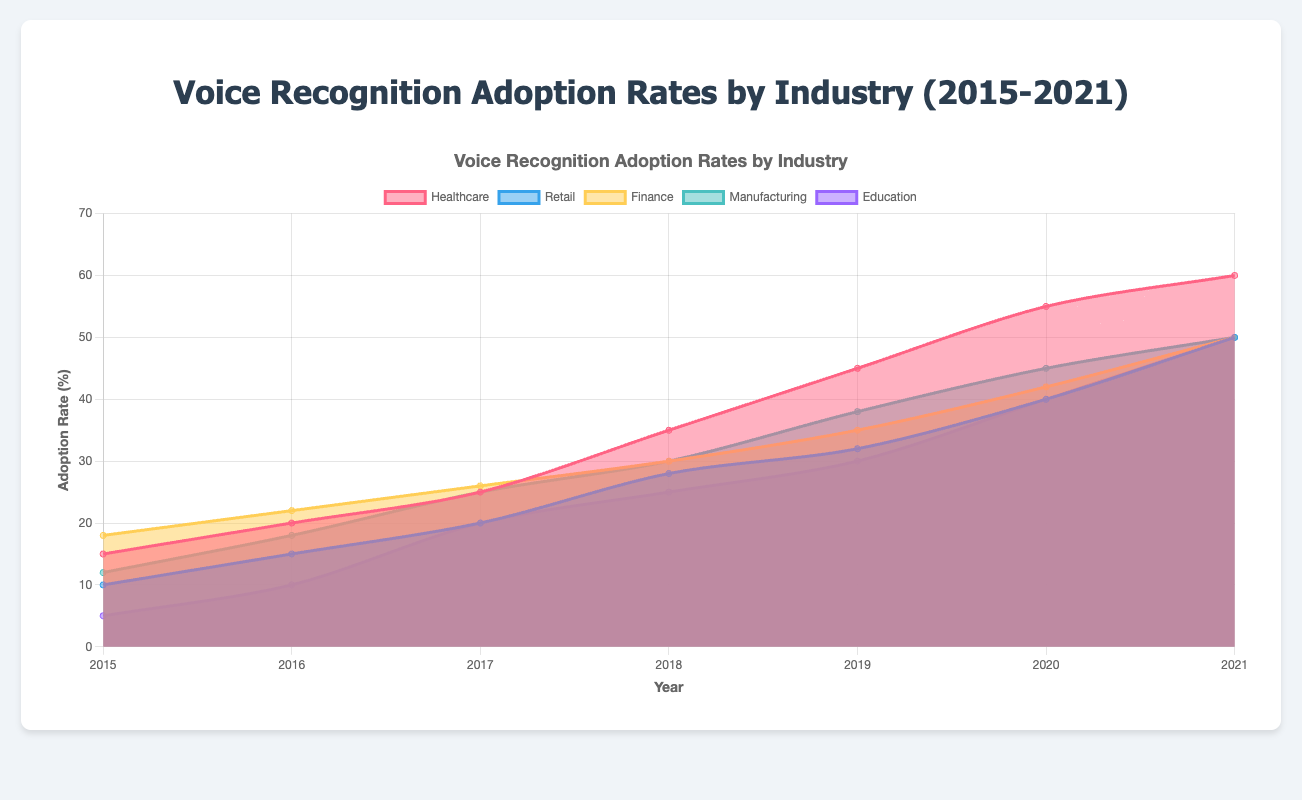What is the title of the chart? The title of the chart is displayed at the top and reads "Voice Recognition Adoption Rates by Industry (2015-2021)."
Answer: Voice Recognition Adoption Rates by Industry (2015-2021) Which industry had the highest adoption rate of voice recognition systems in 2021? The highest adoption rate in 2021 can be identified by comparing the endpoints of the areas for each industry in 2021. The Healthcare industry reaches 60% which is the highest.
Answer: Healthcare What is the difference in adoption rates between Healthcare and Retail in 2020? Look at the adoption rates for Healthcare and Retail in 2020, which are 55% and 40% respectively. The difference is 55% - 40% = 15%.
Answer: 15% Which industry had the least adoption rate in 2015? The lowest adoption rate in 2015 is represented by the smallest area at the starting point of the chart. The Education industry has the smallest area at 5%.
Answer: Education Between which two consecutive years did the Retail industry see the largest increase in adoption rate? To find the largest increase, calculate the difference between consecutive years for Retail: 
2016-2015(15-10=5),
2017-2016(20-15=5),
2018-2017(28-20=8),
2019-2018(32-28=4),
2020-2019(40-32=8),
2021-2020(50-40=10).
The largest increase is between 2020 and 2021.
Answer: 2020 and 2021 What is the total sum of adoption rates for the Manufacturing industry from 2015 to 2021? Sum the adoption rates for Manufacturing from 2015-2021: 12 + 18 + 25 + 30 + 38 + 45 + 50 = 218.
Answer: 218 Which industry showed a consistent increase in adoption rate every year? By observing each industry's trend, all industries consistently increased their adoption rates year over year without any decrease. Therefore, multiple industries showed a consistent increase: Healthcare, Retail, Finance, Manufacturing, and Education.
Answer: Healthcare, Retail, Finance, Manufacturing, Education What was the average adoption rate for the Finance industry over the 7-year period? Calculate the sum of adoption rates for Finance (2015-2021): 18 + 22 + 26 + 30 + 35 + 42 + 50 = 223. The average is 223/7 = 31.86.
Answer: 31.86 Which industry had the fastest growth in adoption rates from 2015 to 2021? To determine the fastest growth, calculate the difference between 2021 and 2015 for each industry:
Healthcare (60-15)=45,
Retail (50-10)=40,
Finance (50-18)=32,
Manufacturing (50-12)=38,
Education (50-5)=45.
Healthcare and Education both have the largest growth of 45%.
Answer: Healthcare and Education 